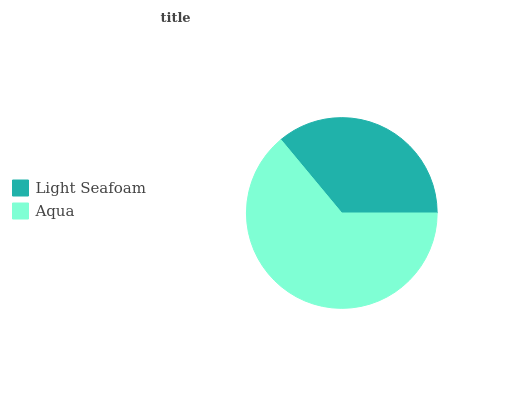Is Light Seafoam the minimum?
Answer yes or no. Yes. Is Aqua the maximum?
Answer yes or no. Yes. Is Aqua the minimum?
Answer yes or no. No. Is Aqua greater than Light Seafoam?
Answer yes or no. Yes. Is Light Seafoam less than Aqua?
Answer yes or no. Yes. Is Light Seafoam greater than Aqua?
Answer yes or no. No. Is Aqua less than Light Seafoam?
Answer yes or no. No. Is Aqua the high median?
Answer yes or no. Yes. Is Light Seafoam the low median?
Answer yes or no. Yes. Is Light Seafoam the high median?
Answer yes or no. No. Is Aqua the low median?
Answer yes or no. No. 